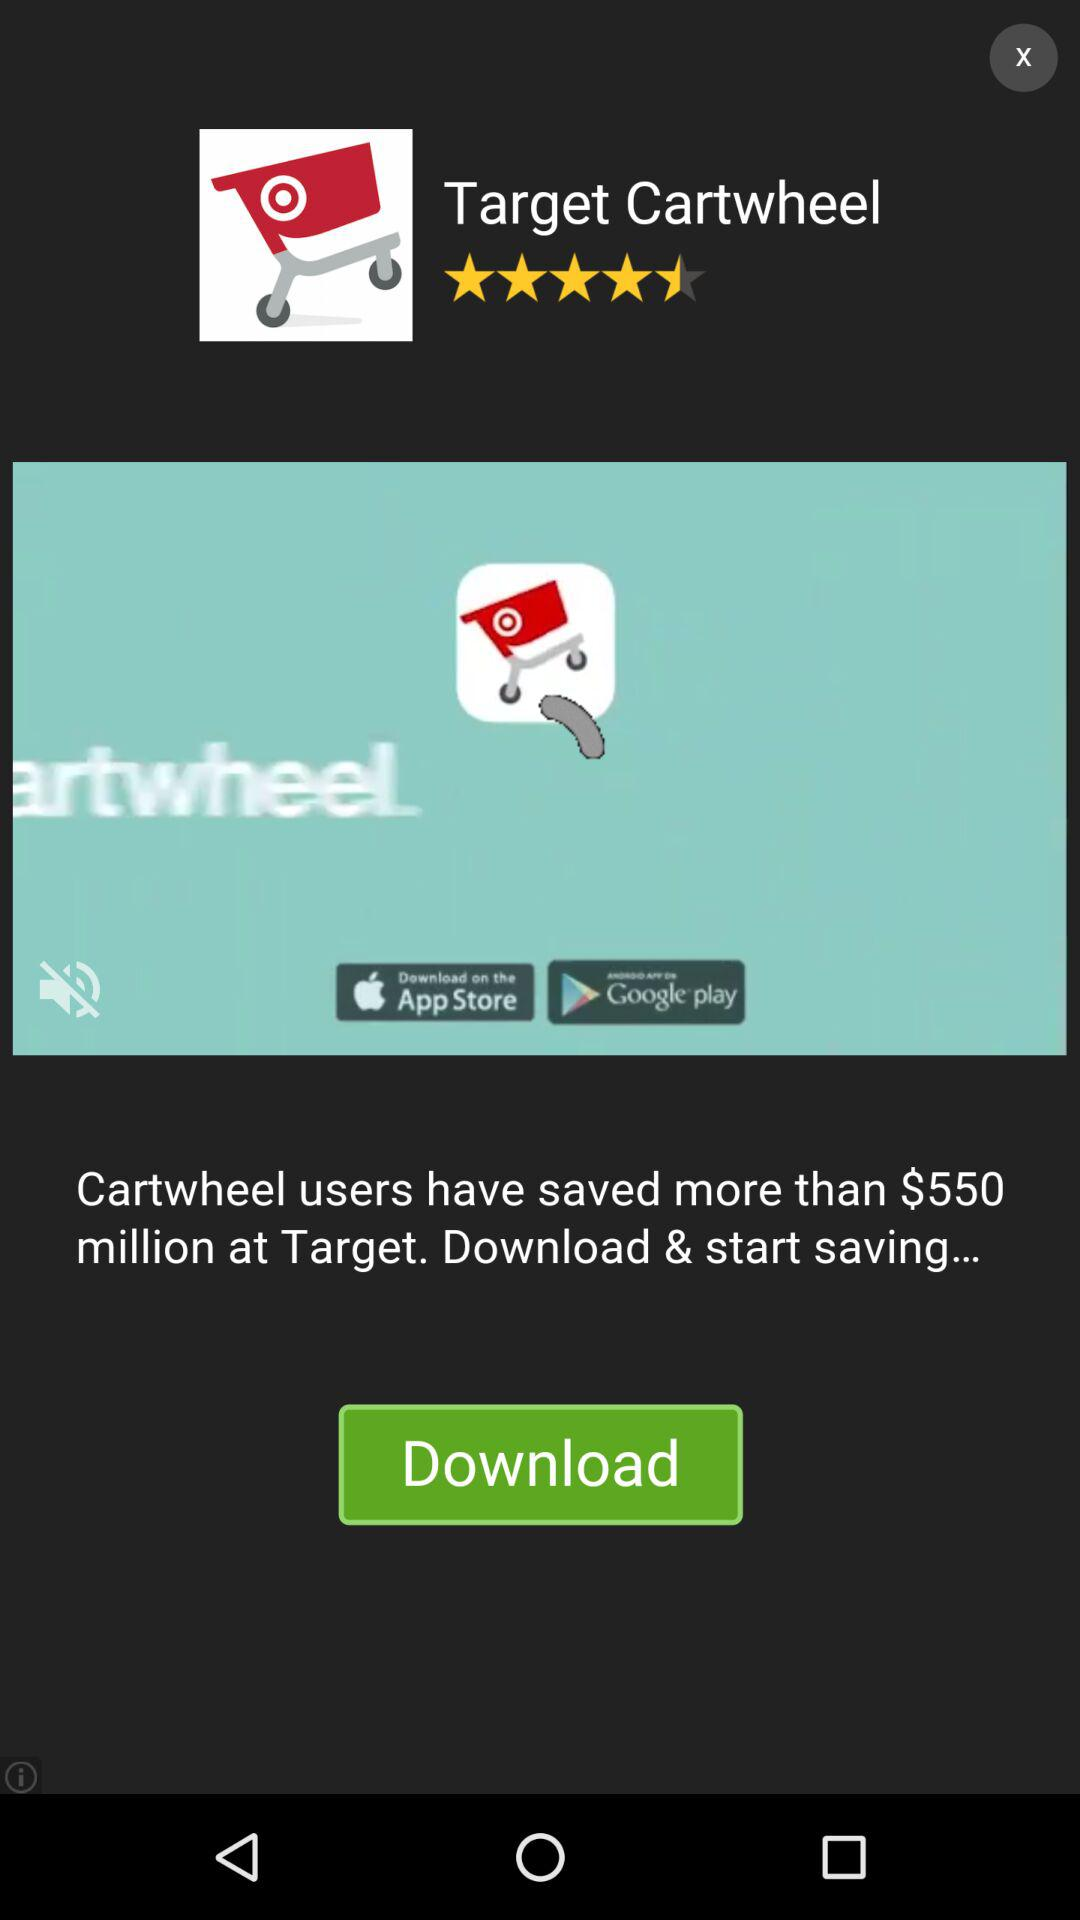How much amount saved by Cartwheel users on achieving target? The amount saved by cartwheel users is $550 million. 